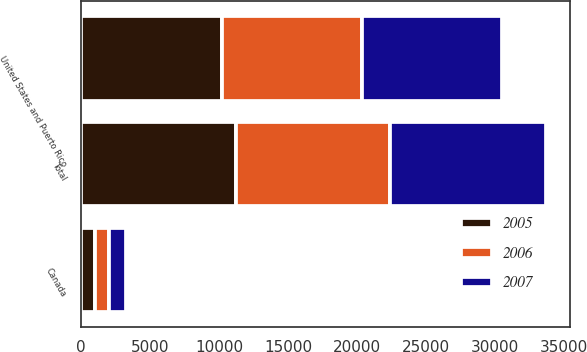Convert chart. <chart><loc_0><loc_0><loc_500><loc_500><stacked_bar_chart><ecel><fcel>United States and Puerto Rico<fcel>Canada<fcel>Total<nl><fcel>2007<fcel>10122<fcel>1229<fcel>11351<nl><fcel>2006<fcel>10163<fcel>1016<fcel>11179<nl><fcel>2005<fcel>10229<fcel>992<fcel>11221<nl></chart> 